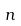Convert formula to latex. <formula><loc_0><loc_0><loc_500><loc_500>n</formula> 